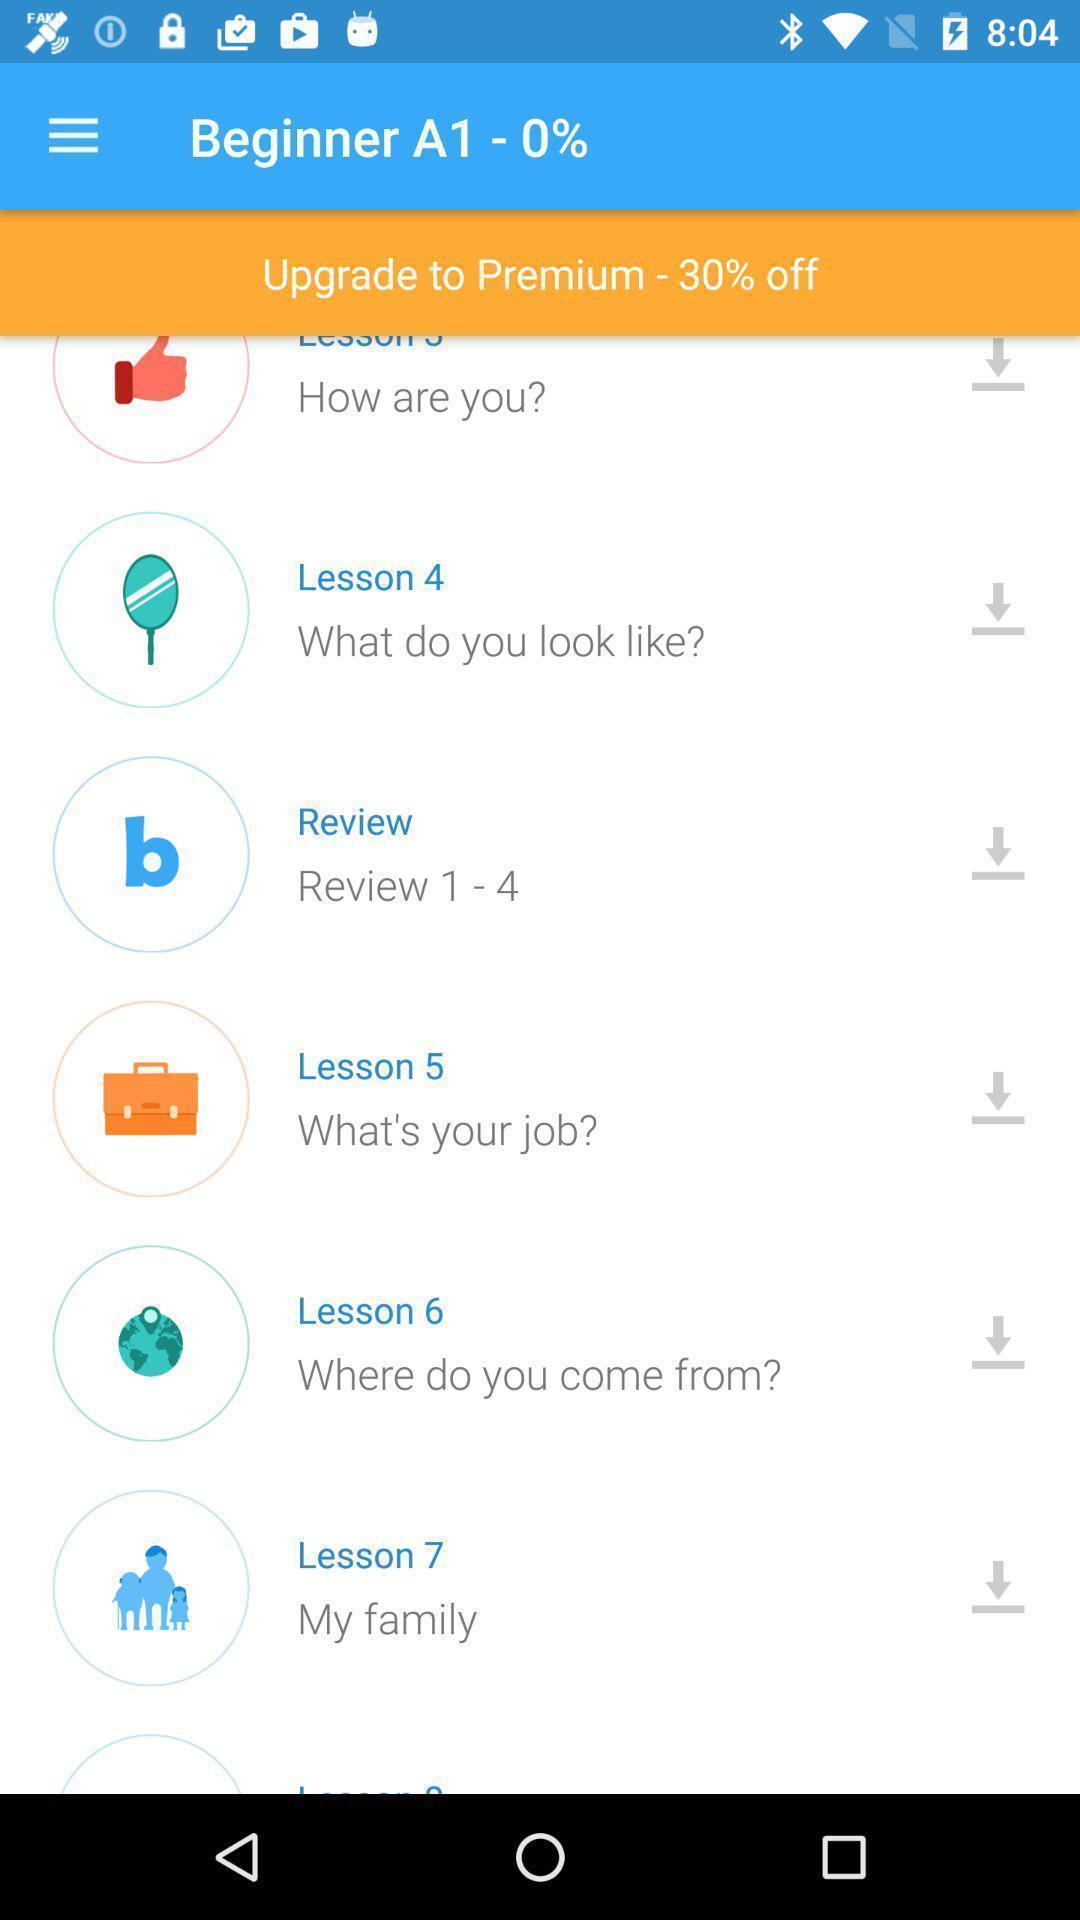Summarize the information in this screenshot. Page showing the list lesson in learning app. 